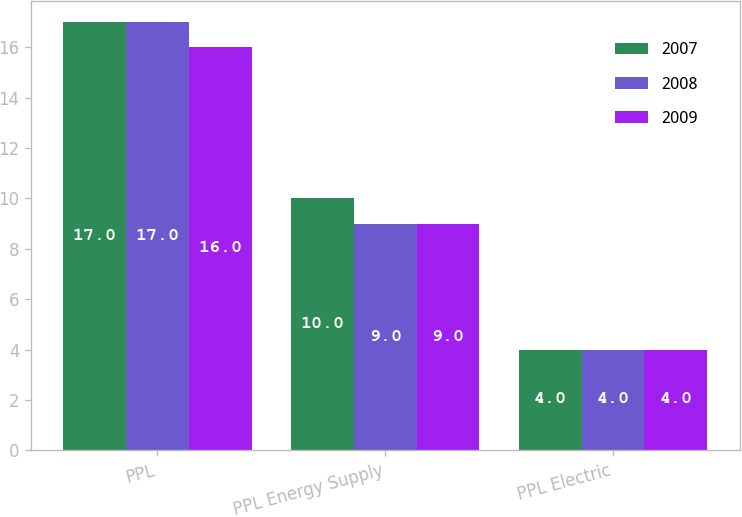Convert chart to OTSL. <chart><loc_0><loc_0><loc_500><loc_500><stacked_bar_chart><ecel><fcel>PPL<fcel>PPL Energy Supply<fcel>PPL Electric<nl><fcel>2007<fcel>17<fcel>10<fcel>4<nl><fcel>2008<fcel>17<fcel>9<fcel>4<nl><fcel>2009<fcel>16<fcel>9<fcel>4<nl></chart> 